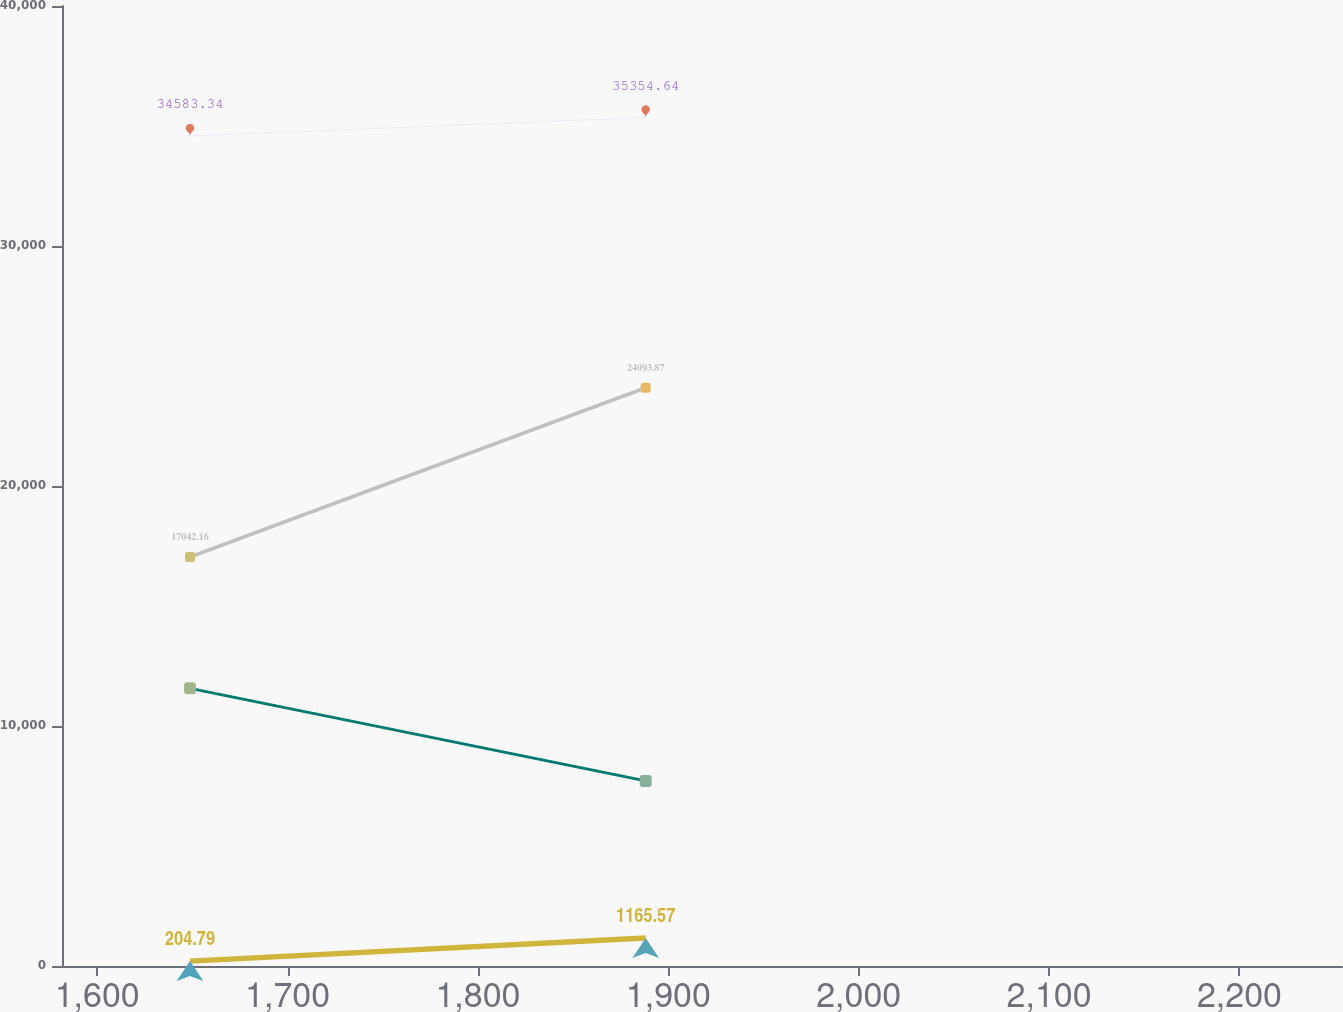Convert chart to OTSL. <chart><loc_0><loc_0><loc_500><loc_500><line_chart><ecel><fcel>Balance at Beginning of the Year<fcel>Balance at End of the Year<fcel>Other(1)<fcel>Allowance for Bad Debts Charged to Expense<nl><fcel>1648.74<fcel>17042.2<fcel>34583.3<fcel>11567.8<fcel>204.79<nl><fcel>1888.11<fcel>24093.9<fcel>35354.6<fcel>7713.33<fcel>1165.57<nl><fcel>2321.11<fcel>28491.8<fcel>42296.4<fcel>11204.2<fcel>3140.17<nl></chart> 